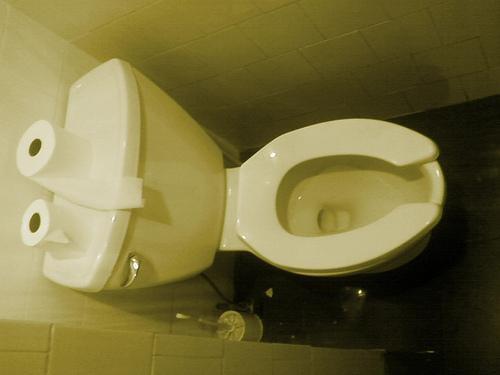How many rolls of toilet paper are visible?
Give a very brief answer. 2. How many toilets are visible?
Give a very brief answer. 1. 